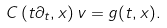<formula> <loc_0><loc_0><loc_500><loc_500>C \left ( t \partial _ { t } , x \right ) v = g ( t , x ) .</formula> 